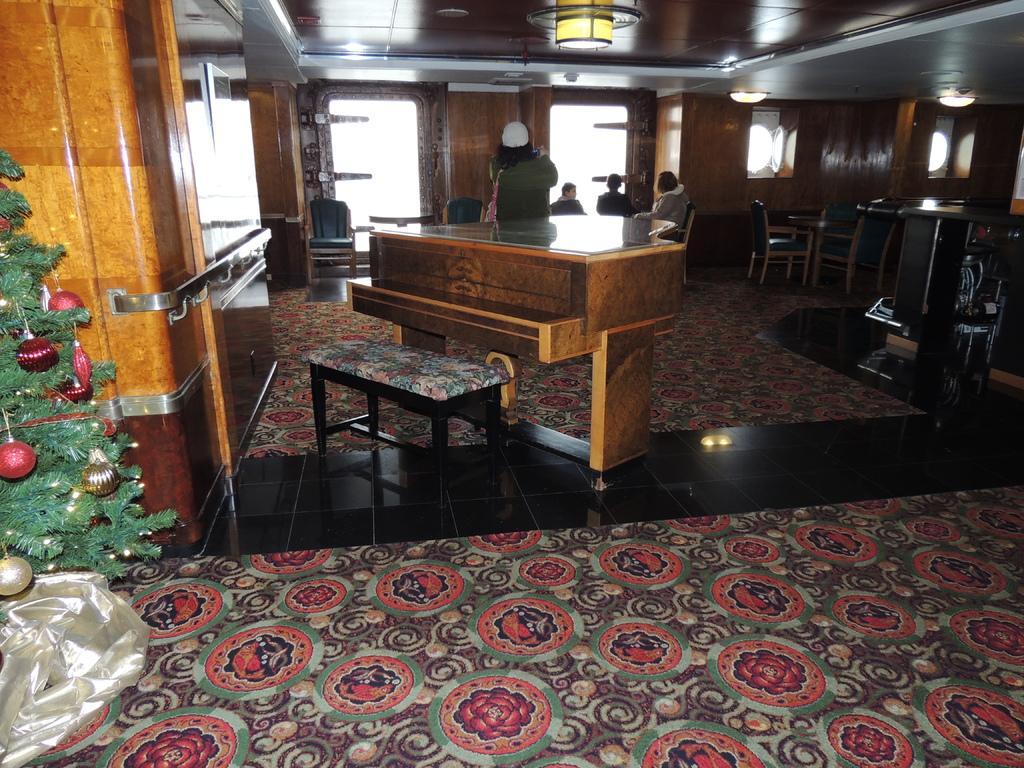Describe this image in one or two sentences. Front there is a piano keyboard and chair. This is a Christmas tree with balls. Floor with carpets. We can able to see number of chairs and tables. Persons are sitting on chair. On top there are lights. This person is standing. 